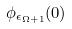<formula> <loc_0><loc_0><loc_500><loc_500>\phi _ { \epsilon _ { \Omega + 1 } } ( 0 )</formula> 